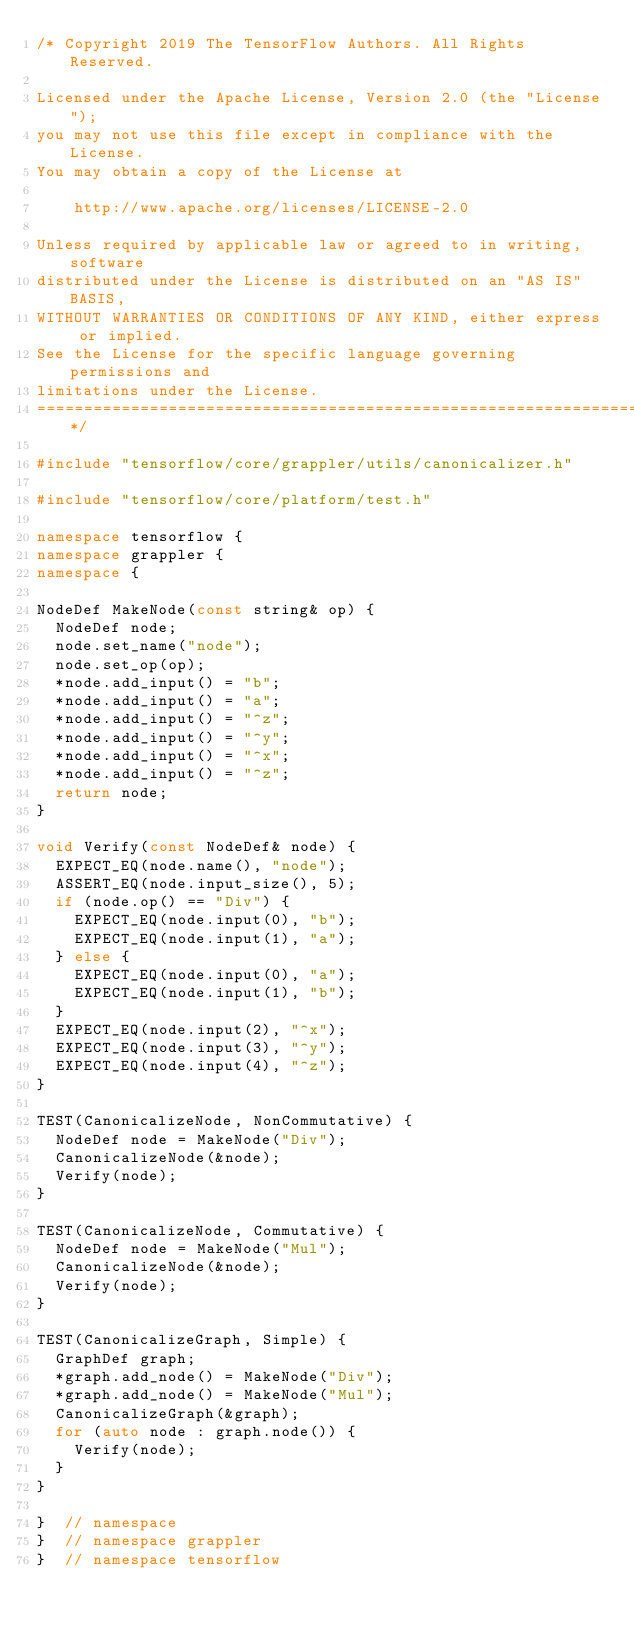<code> <loc_0><loc_0><loc_500><loc_500><_C++_>/* Copyright 2019 The TensorFlow Authors. All Rights Reserved.

Licensed under the Apache License, Version 2.0 (the "License");
you may not use this file except in compliance with the License.
You may obtain a copy of the License at

    http://www.apache.org/licenses/LICENSE-2.0

Unless required by applicable law or agreed to in writing, software
distributed under the License is distributed on an "AS IS" BASIS,
WITHOUT WARRANTIES OR CONDITIONS OF ANY KIND, either express or implied.
See the License for the specific language governing permissions and
limitations under the License.
==============================================================================*/

#include "tensorflow/core/grappler/utils/canonicalizer.h"

#include "tensorflow/core/platform/test.h"

namespace tensorflow {
namespace grappler {
namespace {

NodeDef MakeNode(const string& op) {
  NodeDef node;
  node.set_name("node");
  node.set_op(op);
  *node.add_input() = "b";
  *node.add_input() = "a";
  *node.add_input() = "^z";
  *node.add_input() = "^y";
  *node.add_input() = "^x";
  *node.add_input() = "^z";
  return node;
}

void Verify(const NodeDef& node) {
  EXPECT_EQ(node.name(), "node");
  ASSERT_EQ(node.input_size(), 5);
  if (node.op() == "Div") {
    EXPECT_EQ(node.input(0), "b");
    EXPECT_EQ(node.input(1), "a");
  } else {
    EXPECT_EQ(node.input(0), "a");
    EXPECT_EQ(node.input(1), "b");
  }
  EXPECT_EQ(node.input(2), "^x");
  EXPECT_EQ(node.input(3), "^y");
  EXPECT_EQ(node.input(4), "^z");
}

TEST(CanonicalizeNode, NonCommutative) {
  NodeDef node = MakeNode("Div");
  CanonicalizeNode(&node);
  Verify(node);
}

TEST(CanonicalizeNode, Commutative) {
  NodeDef node = MakeNode("Mul");
  CanonicalizeNode(&node);
  Verify(node);
}

TEST(CanonicalizeGraph, Simple) {
  GraphDef graph;
  *graph.add_node() = MakeNode("Div");
  *graph.add_node() = MakeNode("Mul");
  CanonicalizeGraph(&graph);
  for (auto node : graph.node()) {
    Verify(node);
  }
}

}  // namespace
}  // namespace grappler
}  // namespace tensorflow
</code> 